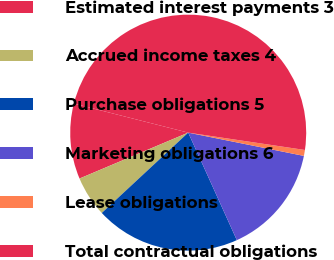Convert chart to OTSL. <chart><loc_0><loc_0><loc_500><loc_500><pie_chart><fcel>Estimated interest payments 3<fcel>Accrued income taxes 4<fcel>Purchase obligations 5<fcel>Marketing obligations 6<fcel>Lease obligations<fcel>Total contractual obligations<nl><fcel>10.32%<fcel>5.56%<fcel>19.84%<fcel>15.08%<fcel>0.81%<fcel>48.39%<nl></chart> 